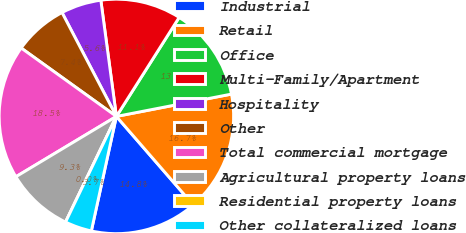Convert chart. <chart><loc_0><loc_0><loc_500><loc_500><pie_chart><fcel>Industrial<fcel>Retail<fcel>Office<fcel>Multi-Family/Apartment<fcel>Hospitality<fcel>Other<fcel>Total commercial mortgage<fcel>Agricultural property loans<fcel>Residential property loans<fcel>Other collateralized loans<nl><fcel>14.81%<fcel>16.67%<fcel>12.96%<fcel>11.11%<fcel>5.56%<fcel>7.41%<fcel>18.52%<fcel>9.26%<fcel>0.0%<fcel>3.71%<nl></chart> 